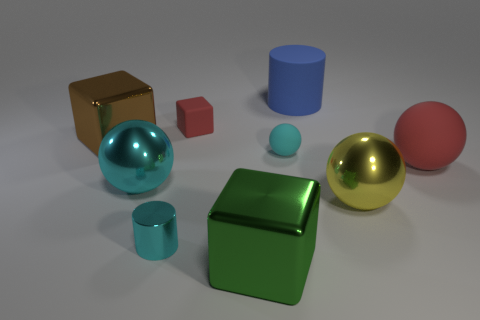Add 1 cyan balls. How many objects exist? 10 Subtract all blocks. How many objects are left? 6 Subtract 0 red cylinders. How many objects are left? 9 Subtract all tiny metal cylinders. Subtract all large green metal blocks. How many objects are left? 7 Add 8 big green shiny cubes. How many big green shiny cubes are left? 9 Add 9 big blue matte objects. How many big blue matte objects exist? 10 